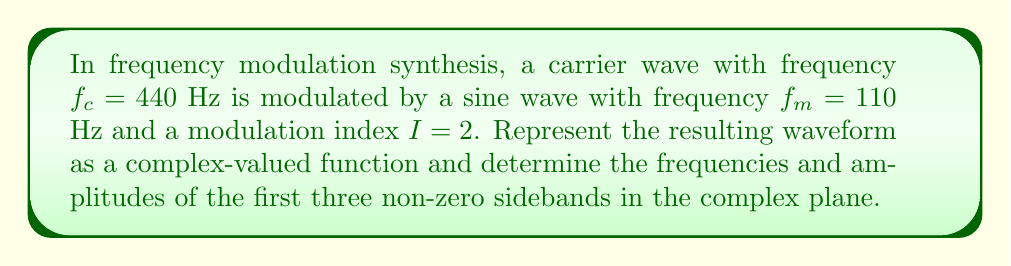Teach me how to tackle this problem. 1) The general form of a frequency-modulated signal in the complex plane is:

   $$s(t) = A e^{j(2\pi f_c t + I \sin(2\pi f_m t))}$$

   where $A$ is the amplitude (we'll assume $A=1$ for simplicity).

2) Expand this using the Jacobi-Anger expansion:

   $$s(t) = \sum_{n=-\infty}^{\infty} J_n(I) e^{j2\pi(f_c + nf_m)t}$$

   where $J_n(I)$ is the Bessel function of the first kind of order $n$.

3) Calculate the Bessel function values for $I=2$ and $n=0,1,2,3$:
   
   $J_0(2) \approx 0.2239$
   $J_1(2) \approx 0.5767$
   $J_2(2) \approx 0.3528$
   $J_3(2) \approx 0.1289$

4) The frequencies of the sidebands are given by $f_c + nf_m$:

   For $n=1$: $440 + 110 = 550$ Hz
   For $n=2$: $440 + 2(110) = 660$ Hz
   For $n=3$: $440 + 3(110) = 770$ Hz

5) The amplitudes of the sidebands are given by $|J_n(I)|$:

   For $n=1$: $|J_1(2)| \approx 0.5767$
   For $n=2$: $|J_2(2)| \approx 0.3528$
   For $n=3$: $|J_3(2)| \approx 0.1289$
Answer: First three non-zero sidebands: (550 Hz, 0.5767), (660 Hz, 0.3528), (770 Hz, 0.1289) 